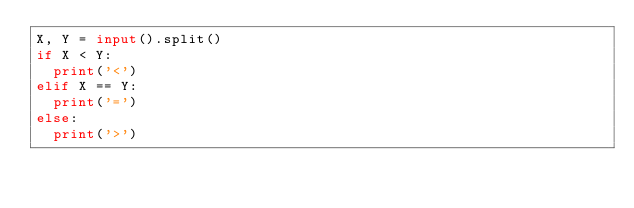<code> <loc_0><loc_0><loc_500><loc_500><_Python_>X, Y = input().split()
if X < Y:
  print('<')
elif X == Y:
  print('=')
else:
  print('>')</code> 